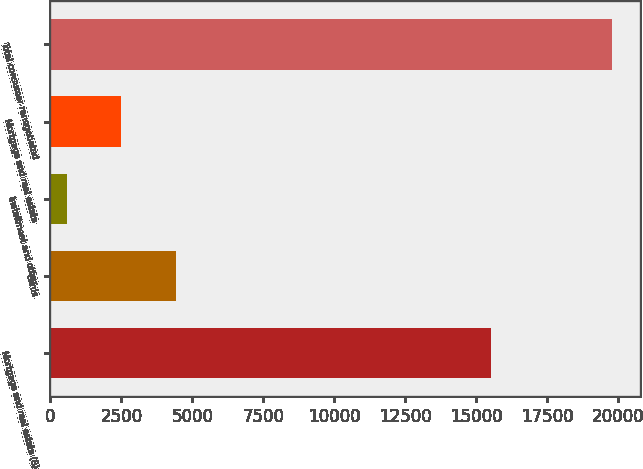Convert chart to OTSL. <chart><loc_0><loc_0><loc_500><loc_500><bar_chart><fcel>Mortgage and real estate (8)<fcel>Cards<fcel>Installment and other<fcel>Mortgage and real estate<fcel>Total consumer renegotiated<nl><fcel>15514<fcel>4420.4<fcel>580<fcel>2500.2<fcel>19782<nl></chart> 